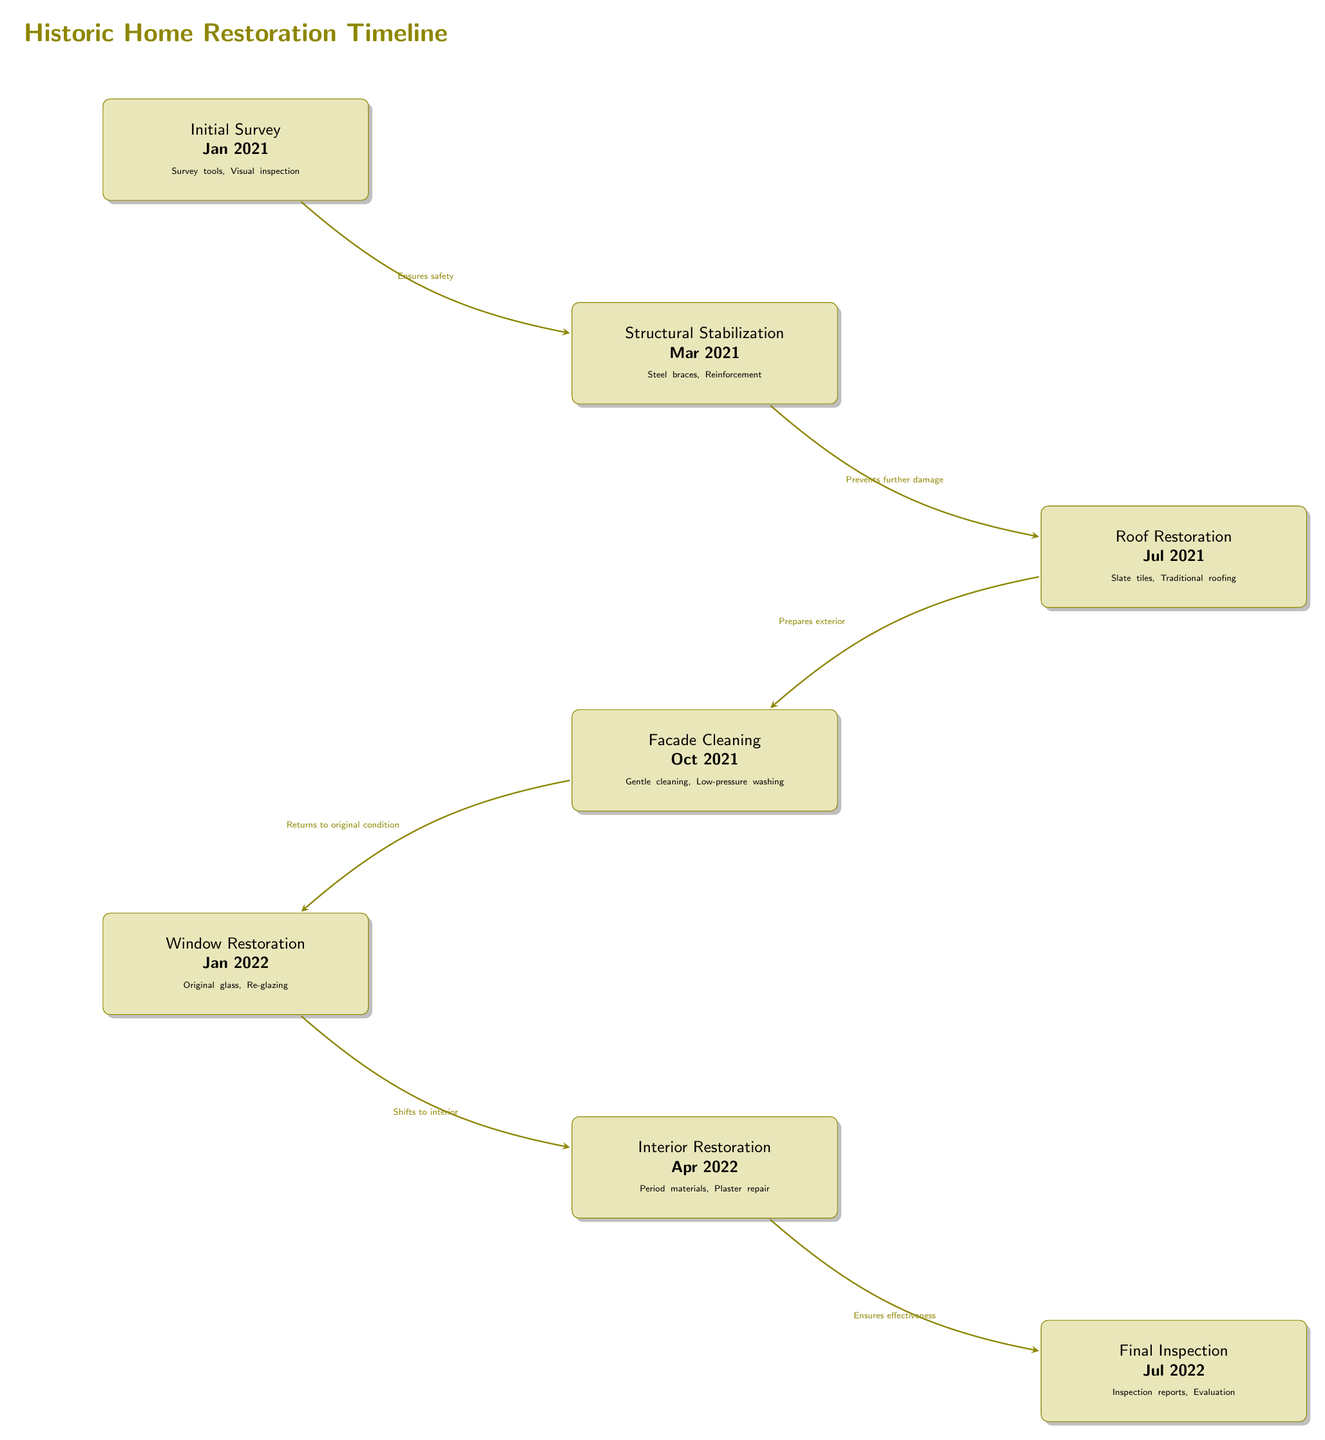What is the first milestone in the restoration timeline? The first milestone listed in the diagram is "Initial Survey" which took place in January 2021.
Answer: Initial Survey Which materials were used during the Roof Restoration step? According to the diagram, the materials used during the Roof Restoration step included "Slate tiles" and "Traditional roofing."
Answer: Slate tiles, Traditional roofing How many significant steps are in the restoration timeline? The diagram showcases a total of seven significant steps in the restoration timeline, represented by the nodes.
Answer: 7 What preservation technique is applied during the Window Restoration phase? The preservation technique mentioned in the Window Restoration phase is "Re-glazing" of the "Original glass."
Answer: Re-glazing What phase directly precedes the Final Inspection node? The phase that precedes the Final Inspection node in the timeline is "Interior Restoration," which occurred in April 2022.
Answer: Interior Restoration What is the purpose of the Structural Stabilization step? The purpose of the Structural Stabilization step, as indicated in the diagram, is to "Prevent further damage."
Answer: Prevents further damage Which step focuses on returning the building to its original condition? The step that focuses on returning the building to its original condition, according to the diagram, is "Facade Cleaning."
Answer: Facade Cleaning What relationship is indicated between the Roof Restoration and Facade Cleaning phases? The diagram shows that Roof Restoration prepares the exterior, leading to the Facade Cleaning phase.
Answer: Prepares exterior 